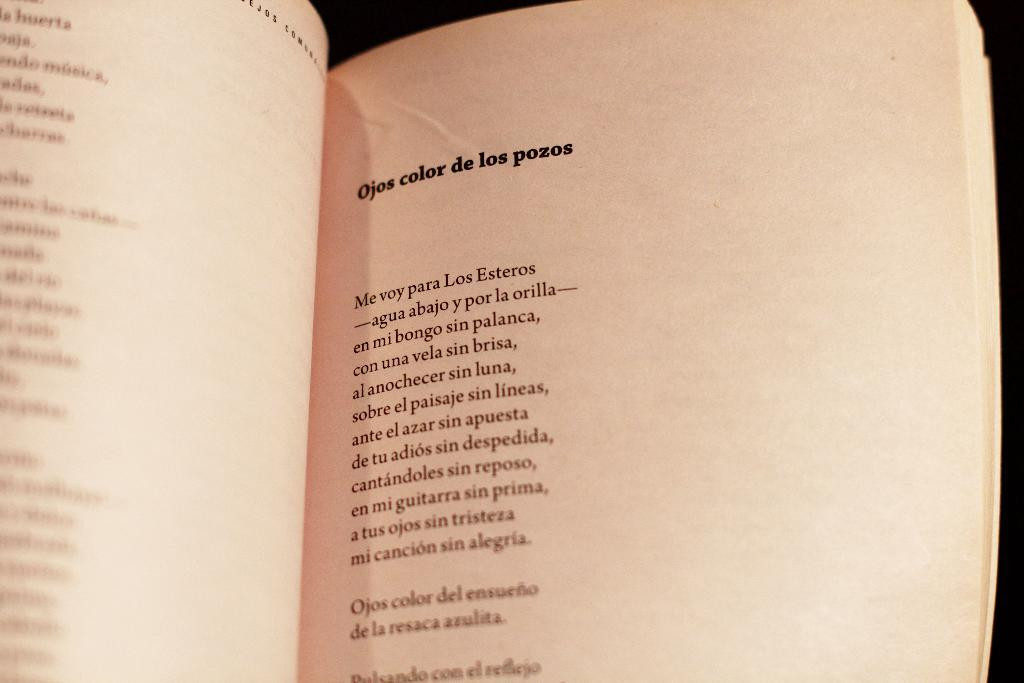<image>
Relay a brief, clear account of the picture shown. A page of a book titled Ojos color de los pozos 